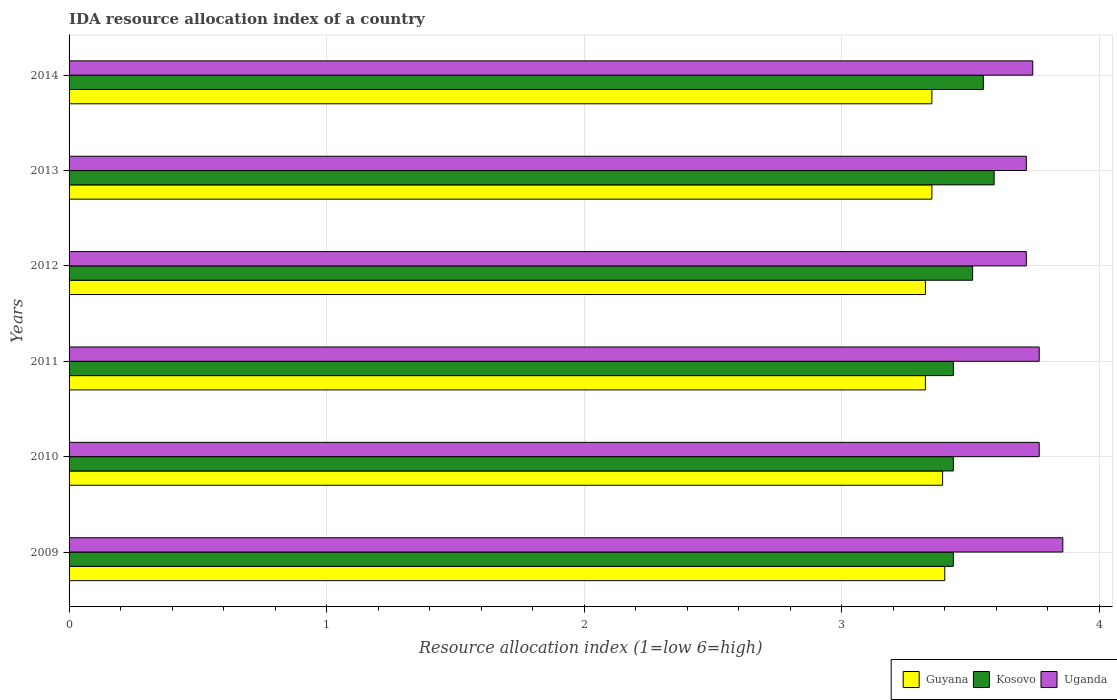How many different coloured bars are there?
Your answer should be very brief. 3. What is the label of the 6th group of bars from the top?
Your response must be concise. 2009. In how many cases, is the number of bars for a given year not equal to the number of legend labels?
Offer a very short reply. 0. What is the IDA resource allocation index in Guyana in 2013?
Make the answer very short. 3.35. Across all years, what is the maximum IDA resource allocation index in Uganda?
Give a very brief answer. 3.86. Across all years, what is the minimum IDA resource allocation index in Guyana?
Keep it short and to the point. 3.33. What is the total IDA resource allocation index in Guyana in the graph?
Ensure brevity in your answer.  20.14. What is the difference between the IDA resource allocation index in Uganda in 2009 and that in 2013?
Ensure brevity in your answer.  0.14. What is the difference between the IDA resource allocation index in Guyana in 2009 and the IDA resource allocation index in Kosovo in 2012?
Your answer should be very brief. -0.11. What is the average IDA resource allocation index in Guyana per year?
Make the answer very short. 3.36. In the year 2013, what is the difference between the IDA resource allocation index in Kosovo and IDA resource allocation index in Guyana?
Your response must be concise. 0.24. In how many years, is the IDA resource allocation index in Guyana greater than 0.4 ?
Provide a short and direct response. 6. What is the ratio of the IDA resource allocation index in Guyana in 2010 to that in 2014?
Keep it short and to the point. 1.01. What is the difference between the highest and the second highest IDA resource allocation index in Uganda?
Offer a very short reply. 0.09. What is the difference between the highest and the lowest IDA resource allocation index in Kosovo?
Your response must be concise. 0.16. In how many years, is the IDA resource allocation index in Uganda greater than the average IDA resource allocation index in Uganda taken over all years?
Ensure brevity in your answer.  3. Is the sum of the IDA resource allocation index in Guyana in 2010 and 2014 greater than the maximum IDA resource allocation index in Uganda across all years?
Offer a terse response. Yes. What does the 3rd bar from the top in 2014 represents?
Ensure brevity in your answer.  Guyana. What does the 2nd bar from the bottom in 2014 represents?
Your response must be concise. Kosovo. Is it the case that in every year, the sum of the IDA resource allocation index in Guyana and IDA resource allocation index in Uganda is greater than the IDA resource allocation index in Kosovo?
Provide a succinct answer. Yes. How many bars are there?
Your answer should be very brief. 18. Are all the bars in the graph horizontal?
Ensure brevity in your answer.  Yes. How many years are there in the graph?
Provide a succinct answer. 6. Where does the legend appear in the graph?
Offer a very short reply. Bottom right. How many legend labels are there?
Keep it short and to the point. 3. What is the title of the graph?
Your response must be concise. IDA resource allocation index of a country. What is the label or title of the X-axis?
Give a very brief answer. Resource allocation index (1=low 6=high). What is the label or title of the Y-axis?
Give a very brief answer. Years. What is the Resource allocation index (1=low 6=high) of Guyana in 2009?
Offer a very short reply. 3.4. What is the Resource allocation index (1=low 6=high) in Kosovo in 2009?
Offer a terse response. 3.43. What is the Resource allocation index (1=low 6=high) of Uganda in 2009?
Keep it short and to the point. 3.86. What is the Resource allocation index (1=low 6=high) in Guyana in 2010?
Keep it short and to the point. 3.39. What is the Resource allocation index (1=low 6=high) in Kosovo in 2010?
Ensure brevity in your answer.  3.43. What is the Resource allocation index (1=low 6=high) of Uganda in 2010?
Provide a short and direct response. 3.77. What is the Resource allocation index (1=low 6=high) of Guyana in 2011?
Ensure brevity in your answer.  3.33. What is the Resource allocation index (1=low 6=high) in Kosovo in 2011?
Your answer should be very brief. 3.43. What is the Resource allocation index (1=low 6=high) of Uganda in 2011?
Offer a terse response. 3.77. What is the Resource allocation index (1=low 6=high) of Guyana in 2012?
Provide a succinct answer. 3.33. What is the Resource allocation index (1=low 6=high) of Kosovo in 2012?
Give a very brief answer. 3.51. What is the Resource allocation index (1=low 6=high) in Uganda in 2012?
Give a very brief answer. 3.72. What is the Resource allocation index (1=low 6=high) in Guyana in 2013?
Your answer should be compact. 3.35. What is the Resource allocation index (1=low 6=high) of Kosovo in 2013?
Your response must be concise. 3.59. What is the Resource allocation index (1=low 6=high) in Uganda in 2013?
Provide a succinct answer. 3.72. What is the Resource allocation index (1=low 6=high) in Guyana in 2014?
Offer a very short reply. 3.35. What is the Resource allocation index (1=low 6=high) in Kosovo in 2014?
Give a very brief answer. 3.55. What is the Resource allocation index (1=low 6=high) in Uganda in 2014?
Offer a terse response. 3.74. Across all years, what is the maximum Resource allocation index (1=low 6=high) of Guyana?
Keep it short and to the point. 3.4. Across all years, what is the maximum Resource allocation index (1=low 6=high) of Kosovo?
Make the answer very short. 3.59. Across all years, what is the maximum Resource allocation index (1=low 6=high) in Uganda?
Your answer should be compact. 3.86. Across all years, what is the minimum Resource allocation index (1=low 6=high) of Guyana?
Provide a succinct answer. 3.33. Across all years, what is the minimum Resource allocation index (1=low 6=high) of Kosovo?
Offer a terse response. 3.43. Across all years, what is the minimum Resource allocation index (1=low 6=high) in Uganda?
Your response must be concise. 3.72. What is the total Resource allocation index (1=low 6=high) of Guyana in the graph?
Offer a terse response. 20.14. What is the total Resource allocation index (1=low 6=high) of Kosovo in the graph?
Your response must be concise. 20.95. What is the total Resource allocation index (1=low 6=high) in Uganda in the graph?
Your response must be concise. 22.57. What is the difference between the Resource allocation index (1=low 6=high) in Guyana in 2009 and that in 2010?
Your answer should be compact. 0.01. What is the difference between the Resource allocation index (1=low 6=high) of Uganda in 2009 and that in 2010?
Provide a short and direct response. 0.09. What is the difference between the Resource allocation index (1=low 6=high) in Guyana in 2009 and that in 2011?
Offer a terse response. 0.07. What is the difference between the Resource allocation index (1=low 6=high) of Kosovo in 2009 and that in 2011?
Your response must be concise. 0. What is the difference between the Resource allocation index (1=low 6=high) of Uganda in 2009 and that in 2011?
Ensure brevity in your answer.  0.09. What is the difference between the Resource allocation index (1=low 6=high) of Guyana in 2009 and that in 2012?
Ensure brevity in your answer.  0.07. What is the difference between the Resource allocation index (1=low 6=high) in Kosovo in 2009 and that in 2012?
Provide a short and direct response. -0.07. What is the difference between the Resource allocation index (1=low 6=high) of Uganda in 2009 and that in 2012?
Your answer should be compact. 0.14. What is the difference between the Resource allocation index (1=low 6=high) in Guyana in 2009 and that in 2013?
Your answer should be very brief. 0.05. What is the difference between the Resource allocation index (1=low 6=high) in Kosovo in 2009 and that in 2013?
Provide a short and direct response. -0.16. What is the difference between the Resource allocation index (1=low 6=high) in Uganda in 2009 and that in 2013?
Provide a succinct answer. 0.14. What is the difference between the Resource allocation index (1=low 6=high) of Kosovo in 2009 and that in 2014?
Your answer should be compact. -0.12. What is the difference between the Resource allocation index (1=low 6=high) of Uganda in 2009 and that in 2014?
Provide a succinct answer. 0.12. What is the difference between the Resource allocation index (1=low 6=high) in Guyana in 2010 and that in 2011?
Make the answer very short. 0.07. What is the difference between the Resource allocation index (1=low 6=high) of Kosovo in 2010 and that in 2011?
Provide a succinct answer. 0. What is the difference between the Resource allocation index (1=low 6=high) of Uganda in 2010 and that in 2011?
Provide a short and direct response. 0. What is the difference between the Resource allocation index (1=low 6=high) in Guyana in 2010 and that in 2012?
Your response must be concise. 0.07. What is the difference between the Resource allocation index (1=low 6=high) in Kosovo in 2010 and that in 2012?
Your answer should be compact. -0.07. What is the difference between the Resource allocation index (1=low 6=high) in Uganda in 2010 and that in 2012?
Your response must be concise. 0.05. What is the difference between the Resource allocation index (1=low 6=high) of Guyana in 2010 and that in 2013?
Give a very brief answer. 0.04. What is the difference between the Resource allocation index (1=low 6=high) in Kosovo in 2010 and that in 2013?
Provide a short and direct response. -0.16. What is the difference between the Resource allocation index (1=low 6=high) of Uganda in 2010 and that in 2013?
Provide a succinct answer. 0.05. What is the difference between the Resource allocation index (1=low 6=high) in Guyana in 2010 and that in 2014?
Offer a terse response. 0.04. What is the difference between the Resource allocation index (1=low 6=high) in Kosovo in 2010 and that in 2014?
Your answer should be very brief. -0.12. What is the difference between the Resource allocation index (1=low 6=high) of Uganda in 2010 and that in 2014?
Provide a succinct answer. 0.03. What is the difference between the Resource allocation index (1=low 6=high) of Kosovo in 2011 and that in 2012?
Your answer should be very brief. -0.07. What is the difference between the Resource allocation index (1=low 6=high) in Guyana in 2011 and that in 2013?
Your response must be concise. -0.03. What is the difference between the Resource allocation index (1=low 6=high) in Kosovo in 2011 and that in 2013?
Your answer should be compact. -0.16. What is the difference between the Resource allocation index (1=low 6=high) of Uganda in 2011 and that in 2013?
Your answer should be compact. 0.05. What is the difference between the Resource allocation index (1=low 6=high) in Guyana in 2011 and that in 2014?
Your answer should be compact. -0.03. What is the difference between the Resource allocation index (1=low 6=high) of Kosovo in 2011 and that in 2014?
Offer a very short reply. -0.12. What is the difference between the Resource allocation index (1=low 6=high) in Uganda in 2011 and that in 2014?
Make the answer very short. 0.03. What is the difference between the Resource allocation index (1=low 6=high) in Guyana in 2012 and that in 2013?
Provide a short and direct response. -0.03. What is the difference between the Resource allocation index (1=low 6=high) in Kosovo in 2012 and that in 2013?
Your answer should be compact. -0.08. What is the difference between the Resource allocation index (1=low 6=high) in Uganda in 2012 and that in 2013?
Your answer should be compact. 0. What is the difference between the Resource allocation index (1=low 6=high) of Guyana in 2012 and that in 2014?
Ensure brevity in your answer.  -0.03. What is the difference between the Resource allocation index (1=low 6=high) of Kosovo in 2012 and that in 2014?
Keep it short and to the point. -0.04. What is the difference between the Resource allocation index (1=low 6=high) of Uganda in 2012 and that in 2014?
Make the answer very short. -0.03. What is the difference between the Resource allocation index (1=low 6=high) in Guyana in 2013 and that in 2014?
Ensure brevity in your answer.  0. What is the difference between the Resource allocation index (1=low 6=high) in Kosovo in 2013 and that in 2014?
Offer a very short reply. 0.04. What is the difference between the Resource allocation index (1=low 6=high) of Uganda in 2013 and that in 2014?
Offer a terse response. -0.03. What is the difference between the Resource allocation index (1=low 6=high) of Guyana in 2009 and the Resource allocation index (1=low 6=high) of Kosovo in 2010?
Make the answer very short. -0.03. What is the difference between the Resource allocation index (1=low 6=high) in Guyana in 2009 and the Resource allocation index (1=low 6=high) in Uganda in 2010?
Offer a terse response. -0.37. What is the difference between the Resource allocation index (1=low 6=high) of Kosovo in 2009 and the Resource allocation index (1=low 6=high) of Uganda in 2010?
Your answer should be compact. -0.33. What is the difference between the Resource allocation index (1=low 6=high) in Guyana in 2009 and the Resource allocation index (1=low 6=high) in Kosovo in 2011?
Your response must be concise. -0.03. What is the difference between the Resource allocation index (1=low 6=high) of Guyana in 2009 and the Resource allocation index (1=low 6=high) of Uganda in 2011?
Offer a terse response. -0.37. What is the difference between the Resource allocation index (1=low 6=high) of Guyana in 2009 and the Resource allocation index (1=low 6=high) of Kosovo in 2012?
Keep it short and to the point. -0.11. What is the difference between the Resource allocation index (1=low 6=high) in Guyana in 2009 and the Resource allocation index (1=low 6=high) in Uganda in 2012?
Your answer should be very brief. -0.32. What is the difference between the Resource allocation index (1=low 6=high) in Kosovo in 2009 and the Resource allocation index (1=low 6=high) in Uganda in 2012?
Keep it short and to the point. -0.28. What is the difference between the Resource allocation index (1=low 6=high) in Guyana in 2009 and the Resource allocation index (1=low 6=high) in Kosovo in 2013?
Your response must be concise. -0.19. What is the difference between the Resource allocation index (1=low 6=high) of Guyana in 2009 and the Resource allocation index (1=low 6=high) of Uganda in 2013?
Make the answer very short. -0.32. What is the difference between the Resource allocation index (1=low 6=high) of Kosovo in 2009 and the Resource allocation index (1=low 6=high) of Uganda in 2013?
Make the answer very short. -0.28. What is the difference between the Resource allocation index (1=low 6=high) of Guyana in 2009 and the Resource allocation index (1=low 6=high) of Uganda in 2014?
Make the answer very short. -0.34. What is the difference between the Resource allocation index (1=low 6=high) in Kosovo in 2009 and the Resource allocation index (1=low 6=high) in Uganda in 2014?
Offer a very short reply. -0.31. What is the difference between the Resource allocation index (1=low 6=high) in Guyana in 2010 and the Resource allocation index (1=low 6=high) in Kosovo in 2011?
Make the answer very short. -0.04. What is the difference between the Resource allocation index (1=low 6=high) in Guyana in 2010 and the Resource allocation index (1=low 6=high) in Uganda in 2011?
Ensure brevity in your answer.  -0.38. What is the difference between the Resource allocation index (1=low 6=high) of Guyana in 2010 and the Resource allocation index (1=low 6=high) of Kosovo in 2012?
Your answer should be compact. -0.12. What is the difference between the Resource allocation index (1=low 6=high) of Guyana in 2010 and the Resource allocation index (1=low 6=high) of Uganda in 2012?
Your response must be concise. -0.33. What is the difference between the Resource allocation index (1=low 6=high) of Kosovo in 2010 and the Resource allocation index (1=low 6=high) of Uganda in 2012?
Provide a succinct answer. -0.28. What is the difference between the Resource allocation index (1=low 6=high) of Guyana in 2010 and the Resource allocation index (1=low 6=high) of Uganda in 2013?
Keep it short and to the point. -0.33. What is the difference between the Resource allocation index (1=low 6=high) of Kosovo in 2010 and the Resource allocation index (1=low 6=high) of Uganda in 2013?
Offer a very short reply. -0.28. What is the difference between the Resource allocation index (1=low 6=high) of Guyana in 2010 and the Resource allocation index (1=low 6=high) of Kosovo in 2014?
Keep it short and to the point. -0.16. What is the difference between the Resource allocation index (1=low 6=high) of Guyana in 2010 and the Resource allocation index (1=low 6=high) of Uganda in 2014?
Keep it short and to the point. -0.35. What is the difference between the Resource allocation index (1=low 6=high) of Kosovo in 2010 and the Resource allocation index (1=low 6=high) of Uganda in 2014?
Your response must be concise. -0.31. What is the difference between the Resource allocation index (1=low 6=high) in Guyana in 2011 and the Resource allocation index (1=low 6=high) in Kosovo in 2012?
Provide a succinct answer. -0.18. What is the difference between the Resource allocation index (1=low 6=high) in Guyana in 2011 and the Resource allocation index (1=low 6=high) in Uganda in 2012?
Your answer should be compact. -0.39. What is the difference between the Resource allocation index (1=low 6=high) in Kosovo in 2011 and the Resource allocation index (1=low 6=high) in Uganda in 2012?
Make the answer very short. -0.28. What is the difference between the Resource allocation index (1=low 6=high) in Guyana in 2011 and the Resource allocation index (1=low 6=high) in Kosovo in 2013?
Provide a succinct answer. -0.27. What is the difference between the Resource allocation index (1=low 6=high) of Guyana in 2011 and the Resource allocation index (1=low 6=high) of Uganda in 2013?
Offer a very short reply. -0.39. What is the difference between the Resource allocation index (1=low 6=high) in Kosovo in 2011 and the Resource allocation index (1=low 6=high) in Uganda in 2013?
Provide a short and direct response. -0.28. What is the difference between the Resource allocation index (1=low 6=high) in Guyana in 2011 and the Resource allocation index (1=low 6=high) in Kosovo in 2014?
Your answer should be compact. -0.23. What is the difference between the Resource allocation index (1=low 6=high) in Guyana in 2011 and the Resource allocation index (1=low 6=high) in Uganda in 2014?
Provide a short and direct response. -0.42. What is the difference between the Resource allocation index (1=low 6=high) in Kosovo in 2011 and the Resource allocation index (1=low 6=high) in Uganda in 2014?
Give a very brief answer. -0.31. What is the difference between the Resource allocation index (1=low 6=high) of Guyana in 2012 and the Resource allocation index (1=low 6=high) of Kosovo in 2013?
Make the answer very short. -0.27. What is the difference between the Resource allocation index (1=low 6=high) in Guyana in 2012 and the Resource allocation index (1=low 6=high) in Uganda in 2013?
Provide a short and direct response. -0.39. What is the difference between the Resource allocation index (1=low 6=high) of Kosovo in 2012 and the Resource allocation index (1=low 6=high) of Uganda in 2013?
Offer a very short reply. -0.21. What is the difference between the Resource allocation index (1=low 6=high) of Guyana in 2012 and the Resource allocation index (1=low 6=high) of Kosovo in 2014?
Your answer should be very brief. -0.23. What is the difference between the Resource allocation index (1=low 6=high) in Guyana in 2012 and the Resource allocation index (1=low 6=high) in Uganda in 2014?
Your answer should be very brief. -0.42. What is the difference between the Resource allocation index (1=low 6=high) of Kosovo in 2012 and the Resource allocation index (1=low 6=high) of Uganda in 2014?
Make the answer very short. -0.23. What is the difference between the Resource allocation index (1=low 6=high) of Guyana in 2013 and the Resource allocation index (1=low 6=high) of Kosovo in 2014?
Your answer should be very brief. -0.2. What is the difference between the Resource allocation index (1=low 6=high) in Guyana in 2013 and the Resource allocation index (1=low 6=high) in Uganda in 2014?
Offer a terse response. -0.39. What is the difference between the Resource allocation index (1=low 6=high) of Kosovo in 2013 and the Resource allocation index (1=low 6=high) of Uganda in 2014?
Give a very brief answer. -0.15. What is the average Resource allocation index (1=low 6=high) in Guyana per year?
Offer a very short reply. 3.36. What is the average Resource allocation index (1=low 6=high) of Kosovo per year?
Offer a terse response. 3.49. What is the average Resource allocation index (1=low 6=high) of Uganda per year?
Ensure brevity in your answer.  3.76. In the year 2009, what is the difference between the Resource allocation index (1=low 6=high) of Guyana and Resource allocation index (1=low 6=high) of Kosovo?
Give a very brief answer. -0.03. In the year 2009, what is the difference between the Resource allocation index (1=low 6=high) of Guyana and Resource allocation index (1=low 6=high) of Uganda?
Your response must be concise. -0.46. In the year 2009, what is the difference between the Resource allocation index (1=low 6=high) of Kosovo and Resource allocation index (1=low 6=high) of Uganda?
Your answer should be very brief. -0.42. In the year 2010, what is the difference between the Resource allocation index (1=low 6=high) in Guyana and Resource allocation index (1=low 6=high) in Kosovo?
Keep it short and to the point. -0.04. In the year 2010, what is the difference between the Resource allocation index (1=low 6=high) of Guyana and Resource allocation index (1=low 6=high) of Uganda?
Provide a short and direct response. -0.38. In the year 2010, what is the difference between the Resource allocation index (1=low 6=high) of Kosovo and Resource allocation index (1=low 6=high) of Uganda?
Keep it short and to the point. -0.33. In the year 2011, what is the difference between the Resource allocation index (1=low 6=high) of Guyana and Resource allocation index (1=low 6=high) of Kosovo?
Offer a very short reply. -0.11. In the year 2011, what is the difference between the Resource allocation index (1=low 6=high) in Guyana and Resource allocation index (1=low 6=high) in Uganda?
Your answer should be compact. -0.44. In the year 2011, what is the difference between the Resource allocation index (1=low 6=high) in Kosovo and Resource allocation index (1=low 6=high) in Uganda?
Your response must be concise. -0.33. In the year 2012, what is the difference between the Resource allocation index (1=low 6=high) in Guyana and Resource allocation index (1=low 6=high) in Kosovo?
Provide a succinct answer. -0.18. In the year 2012, what is the difference between the Resource allocation index (1=low 6=high) in Guyana and Resource allocation index (1=low 6=high) in Uganda?
Make the answer very short. -0.39. In the year 2012, what is the difference between the Resource allocation index (1=low 6=high) in Kosovo and Resource allocation index (1=low 6=high) in Uganda?
Ensure brevity in your answer.  -0.21. In the year 2013, what is the difference between the Resource allocation index (1=low 6=high) in Guyana and Resource allocation index (1=low 6=high) in Kosovo?
Keep it short and to the point. -0.24. In the year 2013, what is the difference between the Resource allocation index (1=low 6=high) in Guyana and Resource allocation index (1=low 6=high) in Uganda?
Your response must be concise. -0.37. In the year 2013, what is the difference between the Resource allocation index (1=low 6=high) in Kosovo and Resource allocation index (1=low 6=high) in Uganda?
Give a very brief answer. -0.12. In the year 2014, what is the difference between the Resource allocation index (1=low 6=high) in Guyana and Resource allocation index (1=low 6=high) in Kosovo?
Offer a very short reply. -0.2. In the year 2014, what is the difference between the Resource allocation index (1=low 6=high) of Guyana and Resource allocation index (1=low 6=high) of Uganda?
Ensure brevity in your answer.  -0.39. In the year 2014, what is the difference between the Resource allocation index (1=low 6=high) in Kosovo and Resource allocation index (1=low 6=high) in Uganda?
Keep it short and to the point. -0.19. What is the ratio of the Resource allocation index (1=low 6=high) of Guyana in 2009 to that in 2010?
Your answer should be very brief. 1. What is the ratio of the Resource allocation index (1=low 6=high) of Uganda in 2009 to that in 2010?
Provide a succinct answer. 1.02. What is the ratio of the Resource allocation index (1=low 6=high) in Guyana in 2009 to that in 2011?
Ensure brevity in your answer.  1.02. What is the ratio of the Resource allocation index (1=low 6=high) in Kosovo in 2009 to that in 2011?
Provide a short and direct response. 1. What is the ratio of the Resource allocation index (1=low 6=high) in Uganda in 2009 to that in 2011?
Provide a short and direct response. 1.02. What is the ratio of the Resource allocation index (1=low 6=high) of Guyana in 2009 to that in 2012?
Give a very brief answer. 1.02. What is the ratio of the Resource allocation index (1=low 6=high) in Kosovo in 2009 to that in 2012?
Make the answer very short. 0.98. What is the ratio of the Resource allocation index (1=low 6=high) of Uganda in 2009 to that in 2012?
Your response must be concise. 1.04. What is the ratio of the Resource allocation index (1=low 6=high) of Guyana in 2009 to that in 2013?
Give a very brief answer. 1.01. What is the ratio of the Resource allocation index (1=low 6=high) of Kosovo in 2009 to that in 2013?
Provide a succinct answer. 0.96. What is the ratio of the Resource allocation index (1=low 6=high) in Uganda in 2009 to that in 2013?
Ensure brevity in your answer.  1.04. What is the ratio of the Resource allocation index (1=low 6=high) in Guyana in 2009 to that in 2014?
Ensure brevity in your answer.  1.01. What is the ratio of the Resource allocation index (1=low 6=high) in Kosovo in 2009 to that in 2014?
Offer a terse response. 0.97. What is the ratio of the Resource allocation index (1=low 6=high) of Uganda in 2009 to that in 2014?
Keep it short and to the point. 1.03. What is the ratio of the Resource allocation index (1=low 6=high) in Guyana in 2010 to that in 2011?
Give a very brief answer. 1.02. What is the ratio of the Resource allocation index (1=low 6=high) in Guyana in 2010 to that in 2012?
Provide a succinct answer. 1.02. What is the ratio of the Resource allocation index (1=low 6=high) of Kosovo in 2010 to that in 2012?
Your answer should be compact. 0.98. What is the ratio of the Resource allocation index (1=low 6=high) in Uganda in 2010 to that in 2012?
Provide a short and direct response. 1.01. What is the ratio of the Resource allocation index (1=low 6=high) of Guyana in 2010 to that in 2013?
Offer a very short reply. 1.01. What is the ratio of the Resource allocation index (1=low 6=high) of Kosovo in 2010 to that in 2013?
Ensure brevity in your answer.  0.96. What is the ratio of the Resource allocation index (1=low 6=high) in Uganda in 2010 to that in 2013?
Keep it short and to the point. 1.01. What is the ratio of the Resource allocation index (1=low 6=high) in Guyana in 2010 to that in 2014?
Your response must be concise. 1.01. What is the ratio of the Resource allocation index (1=low 6=high) of Kosovo in 2010 to that in 2014?
Provide a succinct answer. 0.97. What is the ratio of the Resource allocation index (1=low 6=high) of Uganda in 2010 to that in 2014?
Provide a succinct answer. 1.01. What is the ratio of the Resource allocation index (1=low 6=high) of Kosovo in 2011 to that in 2012?
Offer a terse response. 0.98. What is the ratio of the Resource allocation index (1=low 6=high) of Uganda in 2011 to that in 2012?
Make the answer very short. 1.01. What is the ratio of the Resource allocation index (1=low 6=high) of Kosovo in 2011 to that in 2013?
Keep it short and to the point. 0.96. What is the ratio of the Resource allocation index (1=low 6=high) of Uganda in 2011 to that in 2013?
Provide a short and direct response. 1.01. What is the ratio of the Resource allocation index (1=low 6=high) in Guyana in 2011 to that in 2014?
Your response must be concise. 0.99. What is the ratio of the Resource allocation index (1=low 6=high) in Kosovo in 2011 to that in 2014?
Make the answer very short. 0.97. What is the ratio of the Resource allocation index (1=low 6=high) of Uganda in 2011 to that in 2014?
Provide a succinct answer. 1.01. What is the ratio of the Resource allocation index (1=low 6=high) of Guyana in 2012 to that in 2013?
Your answer should be compact. 0.99. What is the ratio of the Resource allocation index (1=low 6=high) in Kosovo in 2012 to that in 2013?
Offer a very short reply. 0.98. What is the ratio of the Resource allocation index (1=low 6=high) of Uganda in 2012 to that in 2013?
Ensure brevity in your answer.  1. What is the ratio of the Resource allocation index (1=low 6=high) in Kosovo in 2012 to that in 2014?
Your response must be concise. 0.99. What is the ratio of the Resource allocation index (1=low 6=high) in Uganda in 2012 to that in 2014?
Your answer should be compact. 0.99. What is the ratio of the Resource allocation index (1=low 6=high) of Guyana in 2013 to that in 2014?
Make the answer very short. 1. What is the ratio of the Resource allocation index (1=low 6=high) of Kosovo in 2013 to that in 2014?
Your answer should be compact. 1.01. What is the difference between the highest and the second highest Resource allocation index (1=low 6=high) of Guyana?
Provide a succinct answer. 0.01. What is the difference between the highest and the second highest Resource allocation index (1=low 6=high) of Kosovo?
Offer a terse response. 0.04. What is the difference between the highest and the second highest Resource allocation index (1=low 6=high) in Uganda?
Keep it short and to the point. 0.09. What is the difference between the highest and the lowest Resource allocation index (1=low 6=high) in Guyana?
Ensure brevity in your answer.  0.07. What is the difference between the highest and the lowest Resource allocation index (1=low 6=high) of Kosovo?
Your answer should be compact. 0.16. What is the difference between the highest and the lowest Resource allocation index (1=low 6=high) of Uganda?
Your answer should be very brief. 0.14. 